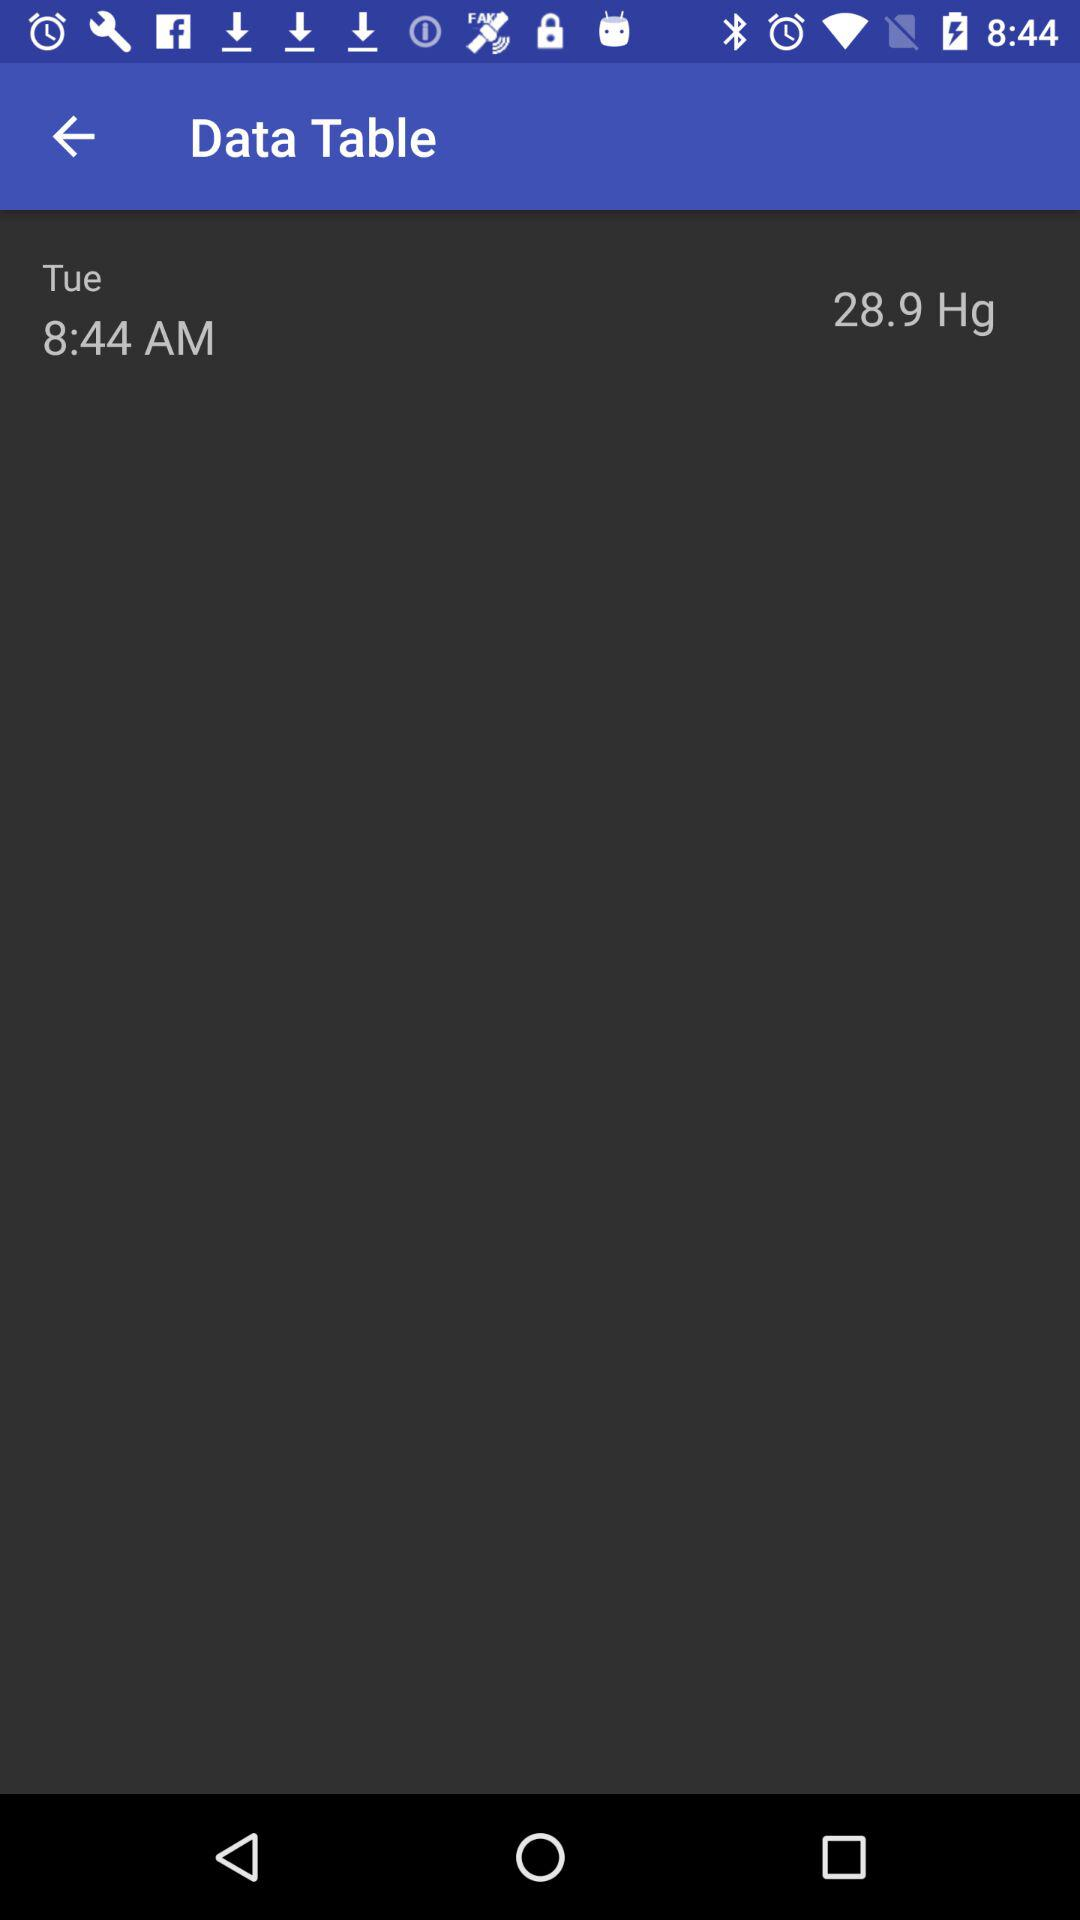What day is it that is displayed on the screen? The day that is displayed on the screen is Tuesday. 